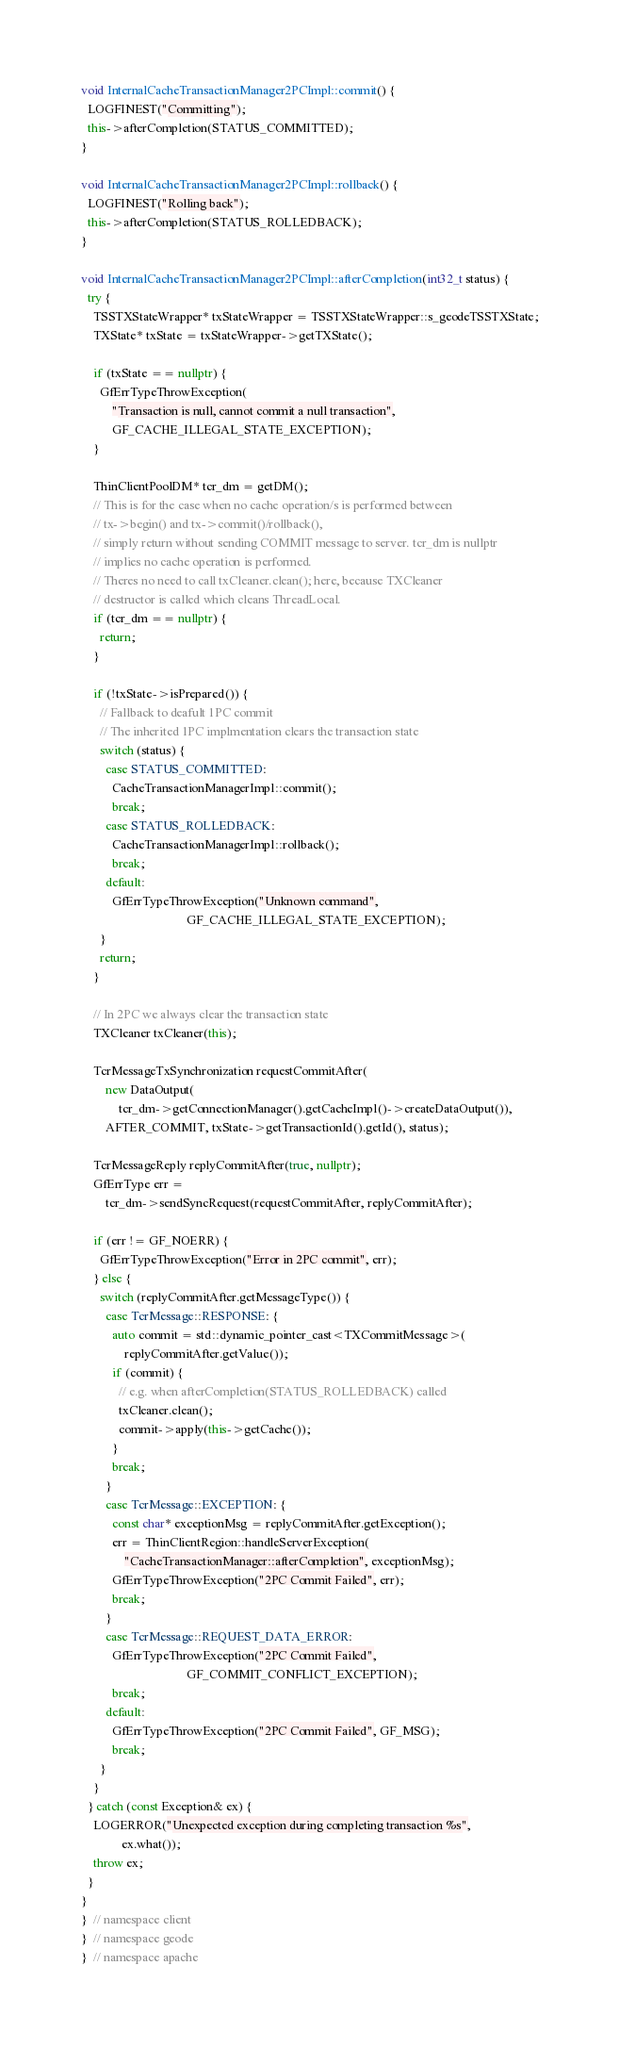Convert code to text. <code><loc_0><loc_0><loc_500><loc_500><_C++_>void InternalCacheTransactionManager2PCImpl::commit() {
  LOGFINEST("Committing");
  this->afterCompletion(STATUS_COMMITTED);
}

void InternalCacheTransactionManager2PCImpl::rollback() {
  LOGFINEST("Rolling back");
  this->afterCompletion(STATUS_ROLLEDBACK);
}

void InternalCacheTransactionManager2PCImpl::afterCompletion(int32_t status) {
  try {
    TSSTXStateWrapper* txStateWrapper = TSSTXStateWrapper::s_geodeTSSTXState;
    TXState* txState = txStateWrapper->getTXState();

    if (txState == nullptr) {
      GfErrTypeThrowException(
          "Transaction is null, cannot commit a null transaction",
          GF_CACHE_ILLEGAL_STATE_EXCEPTION);
    }

    ThinClientPoolDM* tcr_dm = getDM();
    // This is for the case when no cache operation/s is performed between
    // tx->begin() and tx->commit()/rollback(),
    // simply return without sending COMMIT message to server. tcr_dm is nullptr
    // implies no cache operation is performed.
    // Theres no need to call txCleaner.clean(); here, because TXCleaner
    // destructor is called which cleans ThreadLocal.
    if (tcr_dm == nullptr) {
      return;
    }

    if (!txState->isPrepared()) {
      // Fallback to deafult 1PC commit
      // The inherited 1PC implmentation clears the transaction state
      switch (status) {
        case STATUS_COMMITTED:
          CacheTransactionManagerImpl::commit();
          break;
        case STATUS_ROLLEDBACK:
          CacheTransactionManagerImpl::rollback();
          break;
        default:
          GfErrTypeThrowException("Unknown command",
                                  GF_CACHE_ILLEGAL_STATE_EXCEPTION);
      }
      return;
    }

    // In 2PC we always clear the transaction state
    TXCleaner txCleaner(this);

    TcrMessageTxSynchronization requestCommitAfter(
        new DataOutput(
            tcr_dm->getConnectionManager().getCacheImpl()->createDataOutput()),
        AFTER_COMMIT, txState->getTransactionId().getId(), status);

    TcrMessageReply replyCommitAfter(true, nullptr);
    GfErrType err =
        tcr_dm->sendSyncRequest(requestCommitAfter, replyCommitAfter);

    if (err != GF_NOERR) {
      GfErrTypeThrowException("Error in 2PC commit", err);
    } else {
      switch (replyCommitAfter.getMessageType()) {
        case TcrMessage::RESPONSE: {
          auto commit = std::dynamic_pointer_cast<TXCommitMessage>(
              replyCommitAfter.getValue());
          if (commit) {
            // e.g. when afterCompletion(STATUS_ROLLEDBACK) called
            txCleaner.clean();
            commit->apply(this->getCache());
          }
          break;
        }
        case TcrMessage::EXCEPTION: {
          const char* exceptionMsg = replyCommitAfter.getException();
          err = ThinClientRegion::handleServerException(
              "CacheTransactionManager::afterCompletion", exceptionMsg);
          GfErrTypeThrowException("2PC Commit Failed", err);
          break;
        }
        case TcrMessage::REQUEST_DATA_ERROR:
          GfErrTypeThrowException("2PC Commit Failed",
                                  GF_COMMIT_CONFLICT_EXCEPTION);
          break;
        default:
          GfErrTypeThrowException("2PC Commit Failed", GF_MSG);
          break;
      }
    }
  } catch (const Exception& ex) {
    LOGERROR("Unexpected exception during completing transaction %s",
             ex.what());
    throw ex;
  }
}
}  // namespace client
}  // namespace geode
}  // namespace apache
</code> 